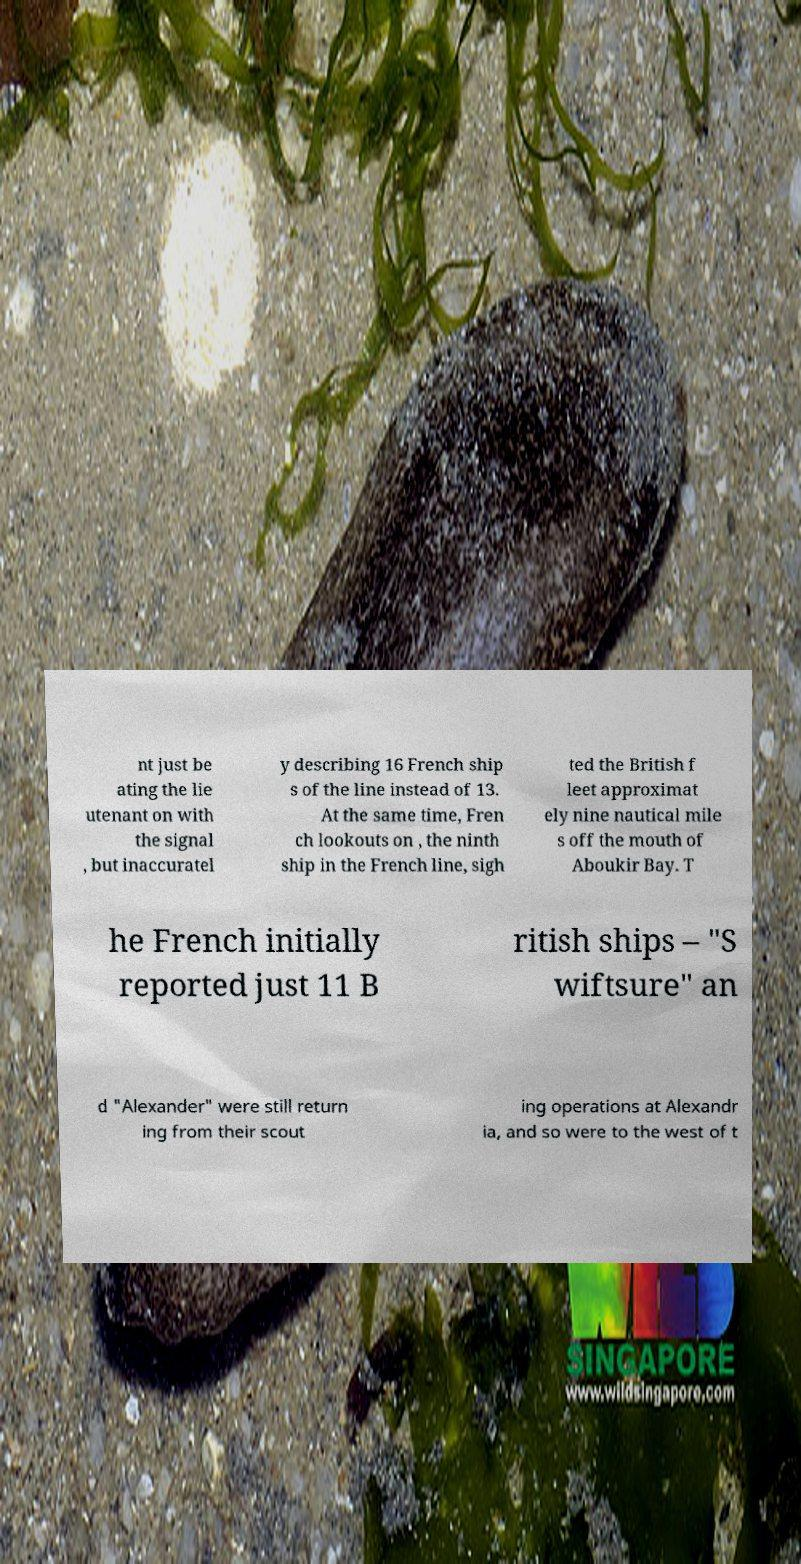For documentation purposes, I need the text within this image transcribed. Could you provide that? nt just be ating the lie utenant on with the signal , but inaccuratel y describing 16 French ship s of the line instead of 13. At the same time, Fren ch lookouts on , the ninth ship in the French line, sigh ted the British f leet approximat ely nine nautical mile s off the mouth of Aboukir Bay. T he French initially reported just 11 B ritish ships – "S wiftsure" an d "Alexander" were still return ing from their scout ing operations at Alexandr ia, and so were to the west of t 